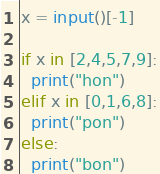Convert code to text. <code><loc_0><loc_0><loc_500><loc_500><_Python_>x = input()[-1]

if x in [2,4,5,7,9]:
  print("hon")
elif x in [0,1,6,8]:
  print("pon")
else:
  print("bon")</code> 